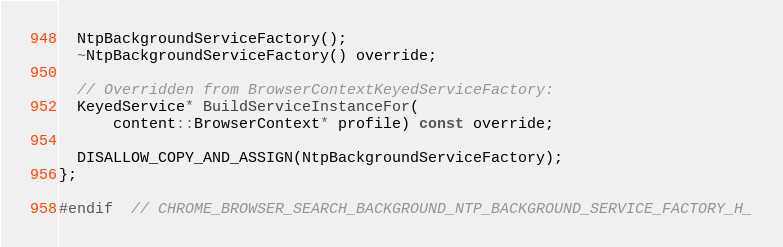Convert code to text. <code><loc_0><loc_0><loc_500><loc_500><_C_>  NtpBackgroundServiceFactory();
  ~NtpBackgroundServiceFactory() override;

  // Overridden from BrowserContextKeyedServiceFactory:
  KeyedService* BuildServiceInstanceFor(
      content::BrowserContext* profile) const override;

  DISALLOW_COPY_AND_ASSIGN(NtpBackgroundServiceFactory);
};

#endif  // CHROME_BROWSER_SEARCH_BACKGROUND_NTP_BACKGROUND_SERVICE_FACTORY_H_
</code> 